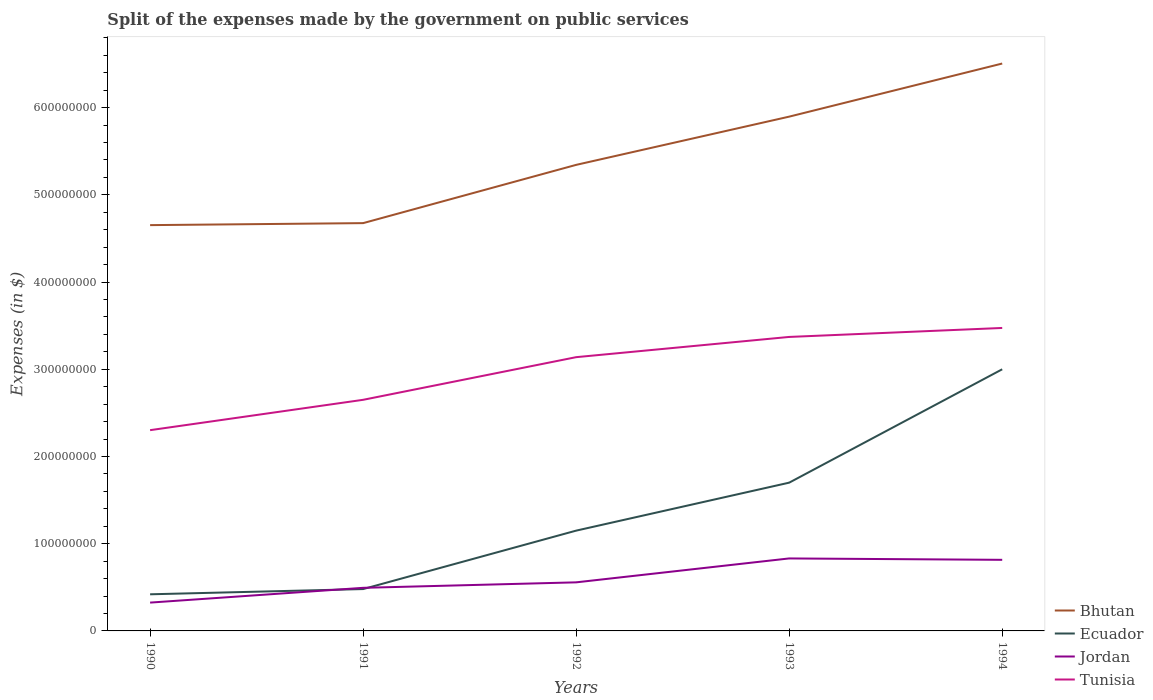How many different coloured lines are there?
Your answer should be compact. 4. Does the line corresponding to Jordan intersect with the line corresponding to Bhutan?
Ensure brevity in your answer.  No. Across all years, what is the maximum expenses made by the government on public services in Tunisia?
Your answer should be very brief. 2.30e+08. What is the total expenses made by the government on public services in Ecuador in the graph?
Offer a terse response. -2.58e+08. What is the difference between the highest and the second highest expenses made by the government on public services in Ecuador?
Give a very brief answer. 2.58e+08. Does the graph contain grids?
Your answer should be very brief. No. Where does the legend appear in the graph?
Provide a short and direct response. Bottom right. How many legend labels are there?
Offer a very short reply. 4. How are the legend labels stacked?
Your answer should be compact. Vertical. What is the title of the graph?
Give a very brief answer. Split of the expenses made by the government on public services. Does "Mauritius" appear as one of the legend labels in the graph?
Your answer should be very brief. No. What is the label or title of the Y-axis?
Offer a very short reply. Expenses (in $). What is the Expenses (in $) in Bhutan in 1990?
Make the answer very short. 4.65e+08. What is the Expenses (in $) in Ecuador in 1990?
Provide a succinct answer. 4.20e+07. What is the Expenses (in $) in Jordan in 1990?
Provide a short and direct response. 3.25e+07. What is the Expenses (in $) in Tunisia in 1990?
Your response must be concise. 2.30e+08. What is the Expenses (in $) of Bhutan in 1991?
Keep it short and to the point. 4.68e+08. What is the Expenses (in $) of Ecuador in 1991?
Your answer should be very brief. 4.80e+07. What is the Expenses (in $) of Jordan in 1991?
Your answer should be very brief. 4.94e+07. What is the Expenses (in $) in Tunisia in 1991?
Keep it short and to the point. 2.65e+08. What is the Expenses (in $) of Bhutan in 1992?
Provide a succinct answer. 5.34e+08. What is the Expenses (in $) of Ecuador in 1992?
Provide a succinct answer. 1.15e+08. What is the Expenses (in $) in Jordan in 1992?
Provide a short and direct response. 5.57e+07. What is the Expenses (in $) of Tunisia in 1992?
Ensure brevity in your answer.  3.14e+08. What is the Expenses (in $) of Bhutan in 1993?
Keep it short and to the point. 5.90e+08. What is the Expenses (in $) of Ecuador in 1993?
Your answer should be very brief. 1.70e+08. What is the Expenses (in $) in Jordan in 1993?
Give a very brief answer. 8.31e+07. What is the Expenses (in $) in Tunisia in 1993?
Your response must be concise. 3.37e+08. What is the Expenses (in $) of Bhutan in 1994?
Offer a terse response. 6.51e+08. What is the Expenses (in $) of Ecuador in 1994?
Your answer should be very brief. 3.00e+08. What is the Expenses (in $) in Jordan in 1994?
Provide a succinct answer. 8.15e+07. What is the Expenses (in $) in Tunisia in 1994?
Make the answer very short. 3.47e+08. Across all years, what is the maximum Expenses (in $) of Bhutan?
Ensure brevity in your answer.  6.51e+08. Across all years, what is the maximum Expenses (in $) in Ecuador?
Your answer should be compact. 3.00e+08. Across all years, what is the maximum Expenses (in $) in Jordan?
Your response must be concise. 8.31e+07. Across all years, what is the maximum Expenses (in $) in Tunisia?
Your response must be concise. 3.47e+08. Across all years, what is the minimum Expenses (in $) in Bhutan?
Provide a succinct answer. 4.65e+08. Across all years, what is the minimum Expenses (in $) of Ecuador?
Your response must be concise. 4.20e+07. Across all years, what is the minimum Expenses (in $) of Jordan?
Ensure brevity in your answer.  3.25e+07. Across all years, what is the minimum Expenses (in $) in Tunisia?
Offer a terse response. 2.30e+08. What is the total Expenses (in $) in Bhutan in the graph?
Keep it short and to the point. 2.71e+09. What is the total Expenses (in $) in Ecuador in the graph?
Your answer should be very brief. 6.75e+08. What is the total Expenses (in $) of Jordan in the graph?
Offer a very short reply. 3.02e+08. What is the total Expenses (in $) of Tunisia in the graph?
Offer a very short reply. 1.49e+09. What is the difference between the Expenses (in $) in Bhutan in 1990 and that in 1991?
Make the answer very short. -2.30e+06. What is the difference between the Expenses (in $) in Ecuador in 1990 and that in 1991?
Keep it short and to the point. -6.00e+06. What is the difference between the Expenses (in $) of Jordan in 1990 and that in 1991?
Provide a short and direct response. -1.69e+07. What is the difference between the Expenses (in $) in Tunisia in 1990 and that in 1991?
Offer a terse response. -3.48e+07. What is the difference between the Expenses (in $) of Bhutan in 1990 and that in 1992?
Ensure brevity in your answer.  -6.91e+07. What is the difference between the Expenses (in $) in Ecuador in 1990 and that in 1992?
Ensure brevity in your answer.  -7.30e+07. What is the difference between the Expenses (in $) of Jordan in 1990 and that in 1992?
Keep it short and to the point. -2.32e+07. What is the difference between the Expenses (in $) in Tunisia in 1990 and that in 1992?
Your response must be concise. -8.37e+07. What is the difference between the Expenses (in $) in Bhutan in 1990 and that in 1993?
Your answer should be very brief. -1.24e+08. What is the difference between the Expenses (in $) of Ecuador in 1990 and that in 1993?
Keep it short and to the point. -1.28e+08. What is the difference between the Expenses (in $) of Jordan in 1990 and that in 1993?
Offer a terse response. -5.06e+07. What is the difference between the Expenses (in $) of Tunisia in 1990 and that in 1993?
Provide a short and direct response. -1.07e+08. What is the difference between the Expenses (in $) of Bhutan in 1990 and that in 1994?
Provide a short and direct response. -1.85e+08. What is the difference between the Expenses (in $) in Ecuador in 1990 and that in 1994?
Give a very brief answer. -2.58e+08. What is the difference between the Expenses (in $) of Jordan in 1990 and that in 1994?
Provide a succinct answer. -4.90e+07. What is the difference between the Expenses (in $) in Tunisia in 1990 and that in 1994?
Keep it short and to the point. -1.17e+08. What is the difference between the Expenses (in $) of Bhutan in 1991 and that in 1992?
Your answer should be compact. -6.68e+07. What is the difference between the Expenses (in $) of Ecuador in 1991 and that in 1992?
Provide a short and direct response. -6.70e+07. What is the difference between the Expenses (in $) of Jordan in 1991 and that in 1992?
Your answer should be very brief. -6.29e+06. What is the difference between the Expenses (in $) of Tunisia in 1991 and that in 1992?
Make the answer very short. -4.89e+07. What is the difference between the Expenses (in $) in Bhutan in 1991 and that in 1993?
Keep it short and to the point. -1.22e+08. What is the difference between the Expenses (in $) of Ecuador in 1991 and that in 1993?
Keep it short and to the point. -1.22e+08. What is the difference between the Expenses (in $) in Jordan in 1991 and that in 1993?
Offer a terse response. -3.37e+07. What is the difference between the Expenses (in $) in Tunisia in 1991 and that in 1993?
Ensure brevity in your answer.  -7.21e+07. What is the difference between the Expenses (in $) in Bhutan in 1991 and that in 1994?
Provide a short and direct response. -1.83e+08. What is the difference between the Expenses (in $) in Ecuador in 1991 and that in 1994?
Keep it short and to the point. -2.52e+08. What is the difference between the Expenses (in $) in Jordan in 1991 and that in 1994?
Give a very brief answer. -3.21e+07. What is the difference between the Expenses (in $) in Tunisia in 1991 and that in 1994?
Ensure brevity in your answer.  -8.24e+07. What is the difference between the Expenses (in $) in Bhutan in 1992 and that in 1993?
Make the answer very short. -5.53e+07. What is the difference between the Expenses (in $) in Ecuador in 1992 and that in 1993?
Your answer should be compact. -5.50e+07. What is the difference between the Expenses (in $) in Jordan in 1992 and that in 1993?
Provide a succinct answer. -2.74e+07. What is the difference between the Expenses (in $) in Tunisia in 1992 and that in 1993?
Offer a terse response. -2.32e+07. What is the difference between the Expenses (in $) in Bhutan in 1992 and that in 1994?
Your answer should be compact. -1.16e+08. What is the difference between the Expenses (in $) in Ecuador in 1992 and that in 1994?
Make the answer very short. -1.85e+08. What is the difference between the Expenses (in $) of Jordan in 1992 and that in 1994?
Your answer should be very brief. -2.58e+07. What is the difference between the Expenses (in $) of Tunisia in 1992 and that in 1994?
Your answer should be compact. -3.35e+07. What is the difference between the Expenses (in $) of Bhutan in 1993 and that in 1994?
Provide a short and direct response. -6.09e+07. What is the difference between the Expenses (in $) in Ecuador in 1993 and that in 1994?
Give a very brief answer. -1.30e+08. What is the difference between the Expenses (in $) in Jordan in 1993 and that in 1994?
Offer a terse response. 1.60e+06. What is the difference between the Expenses (in $) in Tunisia in 1993 and that in 1994?
Ensure brevity in your answer.  -1.03e+07. What is the difference between the Expenses (in $) of Bhutan in 1990 and the Expenses (in $) of Ecuador in 1991?
Make the answer very short. 4.17e+08. What is the difference between the Expenses (in $) of Bhutan in 1990 and the Expenses (in $) of Jordan in 1991?
Your answer should be very brief. 4.16e+08. What is the difference between the Expenses (in $) in Bhutan in 1990 and the Expenses (in $) in Tunisia in 1991?
Your answer should be very brief. 2.00e+08. What is the difference between the Expenses (in $) in Ecuador in 1990 and the Expenses (in $) in Jordan in 1991?
Offer a very short reply. -7.41e+06. What is the difference between the Expenses (in $) in Ecuador in 1990 and the Expenses (in $) in Tunisia in 1991?
Make the answer very short. -2.23e+08. What is the difference between the Expenses (in $) of Jordan in 1990 and the Expenses (in $) of Tunisia in 1991?
Your answer should be compact. -2.33e+08. What is the difference between the Expenses (in $) of Bhutan in 1990 and the Expenses (in $) of Ecuador in 1992?
Keep it short and to the point. 3.50e+08. What is the difference between the Expenses (in $) in Bhutan in 1990 and the Expenses (in $) in Jordan in 1992?
Provide a succinct answer. 4.10e+08. What is the difference between the Expenses (in $) of Bhutan in 1990 and the Expenses (in $) of Tunisia in 1992?
Provide a short and direct response. 1.51e+08. What is the difference between the Expenses (in $) of Ecuador in 1990 and the Expenses (in $) of Jordan in 1992?
Offer a very short reply. -1.37e+07. What is the difference between the Expenses (in $) in Ecuador in 1990 and the Expenses (in $) in Tunisia in 1992?
Provide a short and direct response. -2.72e+08. What is the difference between the Expenses (in $) of Jordan in 1990 and the Expenses (in $) of Tunisia in 1992?
Make the answer very short. -2.81e+08. What is the difference between the Expenses (in $) in Bhutan in 1990 and the Expenses (in $) in Ecuador in 1993?
Make the answer very short. 2.95e+08. What is the difference between the Expenses (in $) of Bhutan in 1990 and the Expenses (in $) of Jordan in 1993?
Provide a short and direct response. 3.82e+08. What is the difference between the Expenses (in $) of Bhutan in 1990 and the Expenses (in $) of Tunisia in 1993?
Keep it short and to the point. 1.28e+08. What is the difference between the Expenses (in $) in Ecuador in 1990 and the Expenses (in $) in Jordan in 1993?
Give a very brief answer. -4.11e+07. What is the difference between the Expenses (in $) of Ecuador in 1990 and the Expenses (in $) of Tunisia in 1993?
Keep it short and to the point. -2.95e+08. What is the difference between the Expenses (in $) of Jordan in 1990 and the Expenses (in $) of Tunisia in 1993?
Ensure brevity in your answer.  -3.05e+08. What is the difference between the Expenses (in $) of Bhutan in 1990 and the Expenses (in $) of Ecuador in 1994?
Keep it short and to the point. 1.65e+08. What is the difference between the Expenses (in $) in Bhutan in 1990 and the Expenses (in $) in Jordan in 1994?
Keep it short and to the point. 3.84e+08. What is the difference between the Expenses (in $) of Bhutan in 1990 and the Expenses (in $) of Tunisia in 1994?
Provide a short and direct response. 1.18e+08. What is the difference between the Expenses (in $) in Ecuador in 1990 and the Expenses (in $) in Jordan in 1994?
Your answer should be very brief. -3.95e+07. What is the difference between the Expenses (in $) of Ecuador in 1990 and the Expenses (in $) of Tunisia in 1994?
Your response must be concise. -3.05e+08. What is the difference between the Expenses (in $) in Jordan in 1990 and the Expenses (in $) in Tunisia in 1994?
Your answer should be very brief. -3.15e+08. What is the difference between the Expenses (in $) of Bhutan in 1991 and the Expenses (in $) of Ecuador in 1992?
Give a very brief answer. 3.53e+08. What is the difference between the Expenses (in $) in Bhutan in 1991 and the Expenses (in $) in Jordan in 1992?
Keep it short and to the point. 4.12e+08. What is the difference between the Expenses (in $) of Bhutan in 1991 and the Expenses (in $) of Tunisia in 1992?
Your response must be concise. 1.54e+08. What is the difference between the Expenses (in $) in Ecuador in 1991 and the Expenses (in $) in Jordan in 1992?
Provide a succinct answer. -7.70e+06. What is the difference between the Expenses (in $) in Ecuador in 1991 and the Expenses (in $) in Tunisia in 1992?
Provide a succinct answer. -2.66e+08. What is the difference between the Expenses (in $) of Jordan in 1991 and the Expenses (in $) of Tunisia in 1992?
Make the answer very short. -2.64e+08. What is the difference between the Expenses (in $) of Bhutan in 1991 and the Expenses (in $) of Ecuador in 1993?
Provide a short and direct response. 2.98e+08. What is the difference between the Expenses (in $) in Bhutan in 1991 and the Expenses (in $) in Jordan in 1993?
Offer a terse response. 3.84e+08. What is the difference between the Expenses (in $) in Bhutan in 1991 and the Expenses (in $) in Tunisia in 1993?
Your response must be concise. 1.30e+08. What is the difference between the Expenses (in $) in Ecuador in 1991 and the Expenses (in $) in Jordan in 1993?
Keep it short and to the point. -3.51e+07. What is the difference between the Expenses (in $) of Ecuador in 1991 and the Expenses (in $) of Tunisia in 1993?
Ensure brevity in your answer.  -2.89e+08. What is the difference between the Expenses (in $) of Jordan in 1991 and the Expenses (in $) of Tunisia in 1993?
Ensure brevity in your answer.  -2.88e+08. What is the difference between the Expenses (in $) of Bhutan in 1991 and the Expenses (in $) of Ecuador in 1994?
Provide a succinct answer. 1.68e+08. What is the difference between the Expenses (in $) of Bhutan in 1991 and the Expenses (in $) of Jordan in 1994?
Offer a very short reply. 3.86e+08. What is the difference between the Expenses (in $) of Bhutan in 1991 and the Expenses (in $) of Tunisia in 1994?
Your answer should be very brief. 1.20e+08. What is the difference between the Expenses (in $) of Ecuador in 1991 and the Expenses (in $) of Jordan in 1994?
Your answer should be compact. -3.35e+07. What is the difference between the Expenses (in $) in Ecuador in 1991 and the Expenses (in $) in Tunisia in 1994?
Offer a very short reply. -2.99e+08. What is the difference between the Expenses (in $) of Jordan in 1991 and the Expenses (in $) of Tunisia in 1994?
Provide a succinct answer. -2.98e+08. What is the difference between the Expenses (in $) in Bhutan in 1992 and the Expenses (in $) in Ecuador in 1993?
Your answer should be compact. 3.64e+08. What is the difference between the Expenses (in $) in Bhutan in 1992 and the Expenses (in $) in Jordan in 1993?
Your answer should be very brief. 4.51e+08. What is the difference between the Expenses (in $) in Bhutan in 1992 and the Expenses (in $) in Tunisia in 1993?
Provide a succinct answer. 1.97e+08. What is the difference between the Expenses (in $) in Ecuador in 1992 and the Expenses (in $) in Jordan in 1993?
Offer a terse response. 3.19e+07. What is the difference between the Expenses (in $) of Ecuador in 1992 and the Expenses (in $) of Tunisia in 1993?
Give a very brief answer. -2.22e+08. What is the difference between the Expenses (in $) in Jordan in 1992 and the Expenses (in $) in Tunisia in 1993?
Provide a short and direct response. -2.81e+08. What is the difference between the Expenses (in $) of Bhutan in 1992 and the Expenses (in $) of Ecuador in 1994?
Ensure brevity in your answer.  2.34e+08. What is the difference between the Expenses (in $) of Bhutan in 1992 and the Expenses (in $) of Jordan in 1994?
Ensure brevity in your answer.  4.53e+08. What is the difference between the Expenses (in $) in Bhutan in 1992 and the Expenses (in $) in Tunisia in 1994?
Your answer should be compact. 1.87e+08. What is the difference between the Expenses (in $) of Ecuador in 1992 and the Expenses (in $) of Jordan in 1994?
Give a very brief answer. 3.35e+07. What is the difference between the Expenses (in $) of Ecuador in 1992 and the Expenses (in $) of Tunisia in 1994?
Give a very brief answer. -2.32e+08. What is the difference between the Expenses (in $) of Jordan in 1992 and the Expenses (in $) of Tunisia in 1994?
Offer a very short reply. -2.92e+08. What is the difference between the Expenses (in $) of Bhutan in 1993 and the Expenses (in $) of Ecuador in 1994?
Ensure brevity in your answer.  2.90e+08. What is the difference between the Expenses (in $) of Bhutan in 1993 and the Expenses (in $) of Jordan in 1994?
Ensure brevity in your answer.  5.08e+08. What is the difference between the Expenses (in $) in Bhutan in 1993 and the Expenses (in $) in Tunisia in 1994?
Offer a terse response. 2.42e+08. What is the difference between the Expenses (in $) in Ecuador in 1993 and the Expenses (in $) in Jordan in 1994?
Keep it short and to the point. 8.85e+07. What is the difference between the Expenses (in $) of Ecuador in 1993 and the Expenses (in $) of Tunisia in 1994?
Offer a very short reply. -1.77e+08. What is the difference between the Expenses (in $) in Jordan in 1993 and the Expenses (in $) in Tunisia in 1994?
Your answer should be very brief. -2.64e+08. What is the average Expenses (in $) in Bhutan per year?
Provide a succinct answer. 5.42e+08. What is the average Expenses (in $) in Ecuador per year?
Make the answer very short. 1.35e+08. What is the average Expenses (in $) in Jordan per year?
Keep it short and to the point. 6.04e+07. What is the average Expenses (in $) in Tunisia per year?
Provide a short and direct response. 2.99e+08. In the year 1990, what is the difference between the Expenses (in $) of Bhutan and Expenses (in $) of Ecuador?
Keep it short and to the point. 4.23e+08. In the year 1990, what is the difference between the Expenses (in $) in Bhutan and Expenses (in $) in Jordan?
Provide a succinct answer. 4.33e+08. In the year 1990, what is the difference between the Expenses (in $) in Bhutan and Expenses (in $) in Tunisia?
Your response must be concise. 2.35e+08. In the year 1990, what is the difference between the Expenses (in $) in Ecuador and Expenses (in $) in Jordan?
Give a very brief answer. 9.53e+06. In the year 1990, what is the difference between the Expenses (in $) in Ecuador and Expenses (in $) in Tunisia?
Offer a terse response. -1.88e+08. In the year 1990, what is the difference between the Expenses (in $) of Jordan and Expenses (in $) of Tunisia?
Provide a succinct answer. -1.98e+08. In the year 1991, what is the difference between the Expenses (in $) of Bhutan and Expenses (in $) of Ecuador?
Your answer should be compact. 4.20e+08. In the year 1991, what is the difference between the Expenses (in $) of Bhutan and Expenses (in $) of Jordan?
Make the answer very short. 4.18e+08. In the year 1991, what is the difference between the Expenses (in $) in Bhutan and Expenses (in $) in Tunisia?
Offer a terse response. 2.03e+08. In the year 1991, what is the difference between the Expenses (in $) of Ecuador and Expenses (in $) of Jordan?
Make the answer very short. -1.41e+06. In the year 1991, what is the difference between the Expenses (in $) of Ecuador and Expenses (in $) of Tunisia?
Offer a terse response. -2.17e+08. In the year 1991, what is the difference between the Expenses (in $) in Jordan and Expenses (in $) in Tunisia?
Make the answer very short. -2.16e+08. In the year 1992, what is the difference between the Expenses (in $) in Bhutan and Expenses (in $) in Ecuador?
Give a very brief answer. 4.19e+08. In the year 1992, what is the difference between the Expenses (in $) of Bhutan and Expenses (in $) of Jordan?
Make the answer very short. 4.79e+08. In the year 1992, what is the difference between the Expenses (in $) of Bhutan and Expenses (in $) of Tunisia?
Ensure brevity in your answer.  2.20e+08. In the year 1992, what is the difference between the Expenses (in $) of Ecuador and Expenses (in $) of Jordan?
Provide a succinct answer. 5.93e+07. In the year 1992, what is the difference between the Expenses (in $) in Ecuador and Expenses (in $) in Tunisia?
Offer a terse response. -1.99e+08. In the year 1992, what is the difference between the Expenses (in $) in Jordan and Expenses (in $) in Tunisia?
Your answer should be compact. -2.58e+08. In the year 1993, what is the difference between the Expenses (in $) of Bhutan and Expenses (in $) of Ecuador?
Make the answer very short. 4.20e+08. In the year 1993, what is the difference between the Expenses (in $) of Bhutan and Expenses (in $) of Jordan?
Your answer should be compact. 5.07e+08. In the year 1993, what is the difference between the Expenses (in $) in Bhutan and Expenses (in $) in Tunisia?
Offer a terse response. 2.53e+08. In the year 1993, what is the difference between the Expenses (in $) of Ecuador and Expenses (in $) of Jordan?
Your answer should be compact. 8.69e+07. In the year 1993, what is the difference between the Expenses (in $) in Ecuador and Expenses (in $) in Tunisia?
Offer a terse response. -1.67e+08. In the year 1993, what is the difference between the Expenses (in $) in Jordan and Expenses (in $) in Tunisia?
Provide a succinct answer. -2.54e+08. In the year 1994, what is the difference between the Expenses (in $) in Bhutan and Expenses (in $) in Ecuador?
Offer a very short reply. 3.51e+08. In the year 1994, what is the difference between the Expenses (in $) of Bhutan and Expenses (in $) of Jordan?
Provide a short and direct response. 5.69e+08. In the year 1994, what is the difference between the Expenses (in $) of Bhutan and Expenses (in $) of Tunisia?
Keep it short and to the point. 3.03e+08. In the year 1994, what is the difference between the Expenses (in $) of Ecuador and Expenses (in $) of Jordan?
Offer a terse response. 2.18e+08. In the year 1994, what is the difference between the Expenses (in $) in Ecuador and Expenses (in $) in Tunisia?
Provide a succinct answer. -4.74e+07. In the year 1994, what is the difference between the Expenses (in $) in Jordan and Expenses (in $) in Tunisia?
Give a very brief answer. -2.66e+08. What is the ratio of the Expenses (in $) in Bhutan in 1990 to that in 1991?
Make the answer very short. 1. What is the ratio of the Expenses (in $) of Jordan in 1990 to that in 1991?
Make the answer very short. 0.66. What is the ratio of the Expenses (in $) in Tunisia in 1990 to that in 1991?
Give a very brief answer. 0.87. What is the ratio of the Expenses (in $) in Bhutan in 1990 to that in 1992?
Ensure brevity in your answer.  0.87. What is the ratio of the Expenses (in $) in Ecuador in 1990 to that in 1992?
Your answer should be compact. 0.37. What is the ratio of the Expenses (in $) in Jordan in 1990 to that in 1992?
Provide a short and direct response. 0.58. What is the ratio of the Expenses (in $) in Tunisia in 1990 to that in 1992?
Your answer should be compact. 0.73. What is the ratio of the Expenses (in $) in Bhutan in 1990 to that in 1993?
Keep it short and to the point. 0.79. What is the ratio of the Expenses (in $) in Ecuador in 1990 to that in 1993?
Your response must be concise. 0.25. What is the ratio of the Expenses (in $) of Jordan in 1990 to that in 1993?
Provide a succinct answer. 0.39. What is the ratio of the Expenses (in $) in Tunisia in 1990 to that in 1993?
Your answer should be compact. 0.68. What is the ratio of the Expenses (in $) of Bhutan in 1990 to that in 1994?
Provide a short and direct response. 0.72. What is the ratio of the Expenses (in $) of Ecuador in 1990 to that in 1994?
Provide a short and direct response. 0.14. What is the ratio of the Expenses (in $) in Jordan in 1990 to that in 1994?
Ensure brevity in your answer.  0.4. What is the ratio of the Expenses (in $) of Tunisia in 1990 to that in 1994?
Provide a succinct answer. 0.66. What is the ratio of the Expenses (in $) of Ecuador in 1991 to that in 1992?
Keep it short and to the point. 0.42. What is the ratio of the Expenses (in $) of Jordan in 1991 to that in 1992?
Offer a very short reply. 0.89. What is the ratio of the Expenses (in $) in Tunisia in 1991 to that in 1992?
Give a very brief answer. 0.84. What is the ratio of the Expenses (in $) in Bhutan in 1991 to that in 1993?
Ensure brevity in your answer.  0.79. What is the ratio of the Expenses (in $) in Ecuador in 1991 to that in 1993?
Provide a succinct answer. 0.28. What is the ratio of the Expenses (in $) of Jordan in 1991 to that in 1993?
Provide a short and direct response. 0.59. What is the ratio of the Expenses (in $) in Tunisia in 1991 to that in 1993?
Offer a terse response. 0.79. What is the ratio of the Expenses (in $) of Bhutan in 1991 to that in 1994?
Provide a succinct answer. 0.72. What is the ratio of the Expenses (in $) of Ecuador in 1991 to that in 1994?
Keep it short and to the point. 0.16. What is the ratio of the Expenses (in $) in Jordan in 1991 to that in 1994?
Your answer should be compact. 0.61. What is the ratio of the Expenses (in $) in Tunisia in 1991 to that in 1994?
Your response must be concise. 0.76. What is the ratio of the Expenses (in $) of Bhutan in 1992 to that in 1993?
Make the answer very short. 0.91. What is the ratio of the Expenses (in $) of Ecuador in 1992 to that in 1993?
Your response must be concise. 0.68. What is the ratio of the Expenses (in $) of Jordan in 1992 to that in 1993?
Offer a very short reply. 0.67. What is the ratio of the Expenses (in $) in Tunisia in 1992 to that in 1993?
Offer a terse response. 0.93. What is the ratio of the Expenses (in $) in Bhutan in 1992 to that in 1994?
Ensure brevity in your answer.  0.82. What is the ratio of the Expenses (in $) of Ecuador in 1992 to that in 1994?
Make the answer very short. 0.38. What is the ratio of the Expenses (in $) of Jordan in 1992 to that in 1994?
Keep it short and to the point. 0.68. What is the ratio of the Expenses (in $) in Tunisia in 1992 to that in 1994?
Your answer should be compact. 0.9. What is the ratio of the Expenses (in $) of Bhutan in 1993 to that in 1994?
Ensure brevity in your answer.  0.91. What is the ratio of the Expenses (in $) in Ecuador in 1993 to that in 1994?
Your response must be concise. 0.57. What is the ratio of the Expenses (in $) in Jordan in 1993 to that in 1994?
Offer a very short reply. 1.02. What is the ratio of the Expenses (in $) in Tunisia in 1993 to that in 1994?
Your answer should be very brief. 0.97. What is the difference between the highest and the second highest Expenses (in $) of Bhutan?
Provide a short and direct response. 6.09e+07. What is the difference between the highest and the second highest Expenses (in $) of Ecuador?
Give a very brief answer. 1.30e+08. What is the difference between the highest and the second highest Expenses (in $) in Jordan?
Make the answer very short. 1.60e+06. What is the difference between the highest and the second highest Expenses (in $) of Tunisia?
Offer a very short reply. 1.03e+07. What is the difference between the highest and the lowest Expenses (in $) of Bhutan?
Provide a short and direct response. 1.85e+08. What is the difference between the highest and the lowest Expenses (in $) in Ecuador?
Keep it short and to the point. 2.58e+08. What is the difference between the highest and the lowest Expenses (in $) in Jordan?
Ensure brevity in your answer.  5.06e+07. What is the difference between the highest and the lowest Expenses (in $) of Tunisia?
Give a very brief answer. 1.17e+08. 